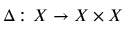<formula> <loc_0><loc_0><loc_500><loc_500>\Delta \colon X \to X \times X</formula> 